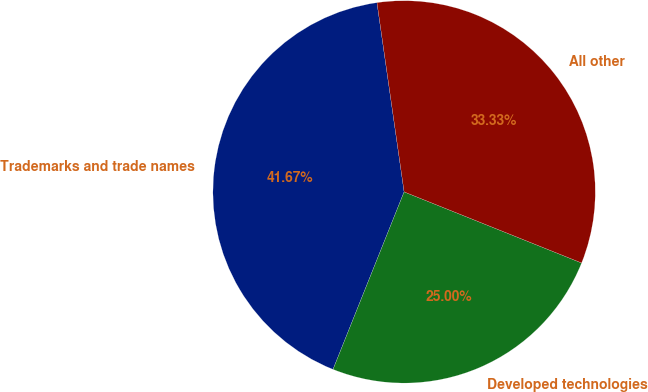Convert chart. <chart><loc_0><loc_0><loc_500><loc_500><pie_chart><fcel>Trademarks and trade names<fcel>Developed technologies<fcel>All other<nl><fcel>41.67%<fcel>25.0%<fcel>33.33%<nl></chart> 